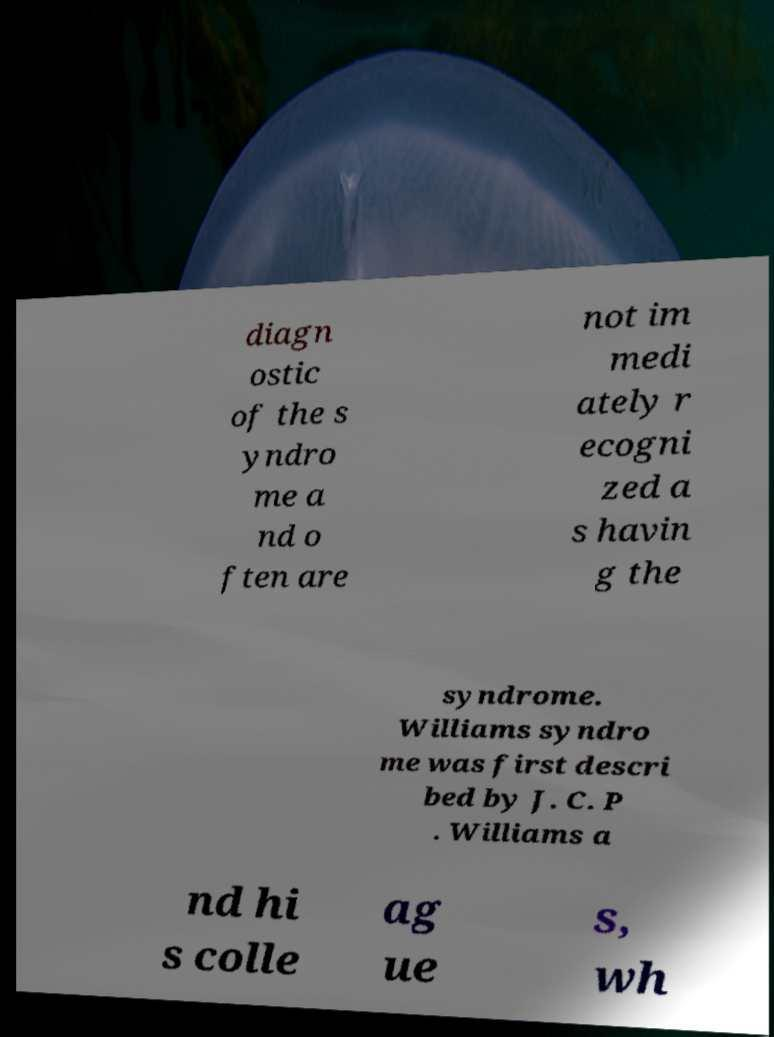Could you assist in decoding the text presented in this image and type it out clearly? diagn ostic of the s yndro me a nd o ften are not im medi ately r ecogni zed a s havin g the syndrome. Williams syndro me was first descri bed by J. C. P . Williams a nd hi s colle ag ue s, wh 